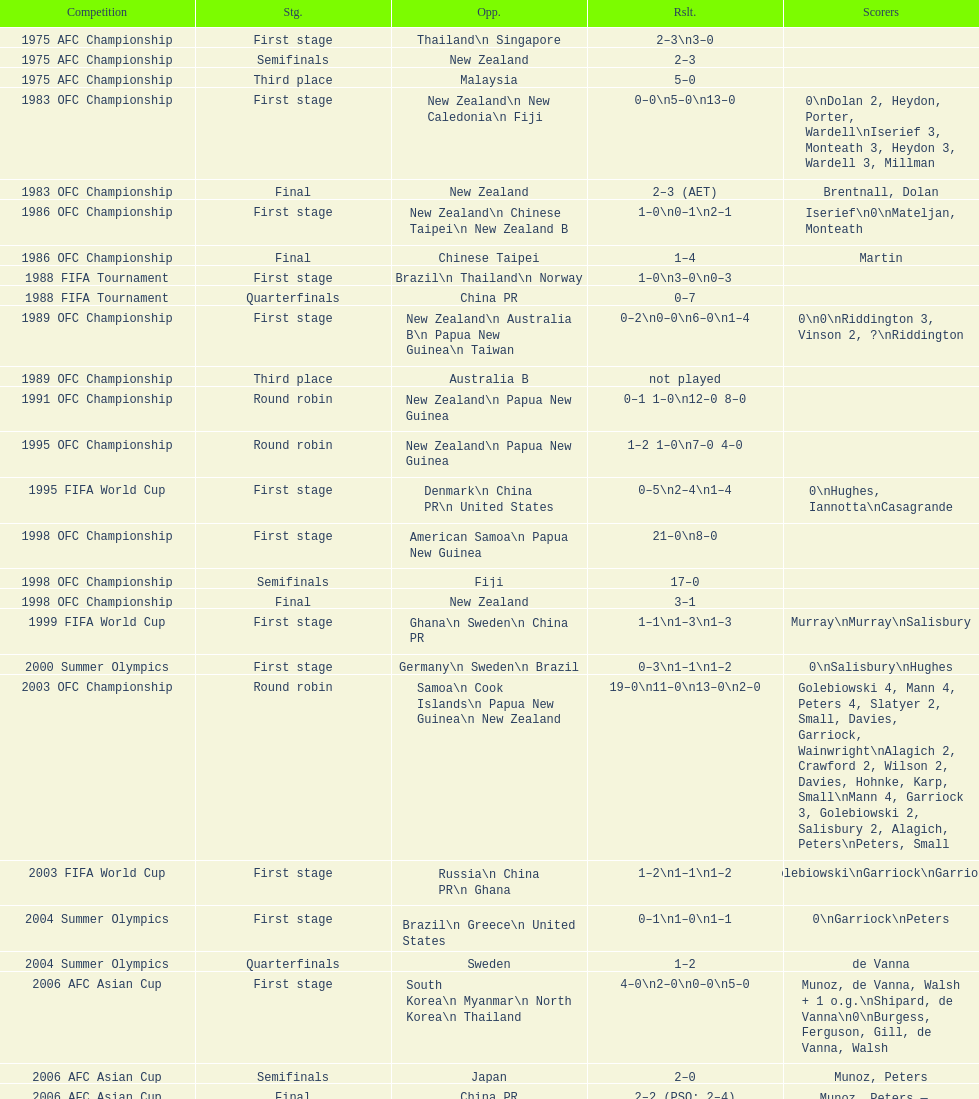What is the total number of competitions? 21. 